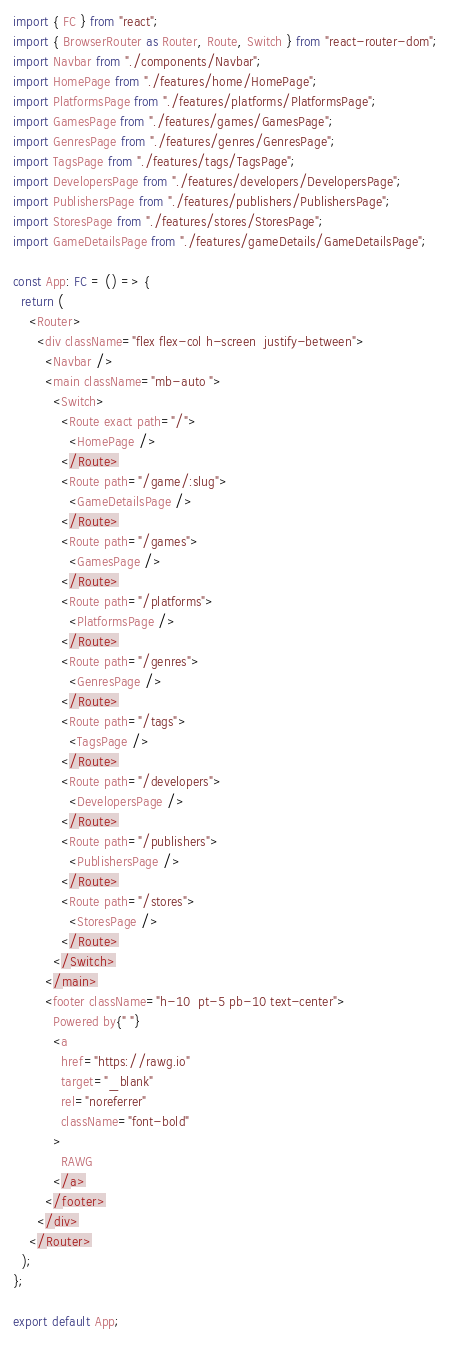<code> <loc_0><loc_0><loc_500><loc_500><_TypeScript_>import { FC } from "react";
import { BrowserRouter as Router, Route, Switch } from "react-router-dom";
import Navbar from "./components/Navbar";
import HomePage from "./features/home/HomePage";
import PlatformsPage from "./features/platforms/PlatformsPage";
import GamesPage from "./features/games/GamesPage";
import GenresPage from "./features/genres/GenresPage";
import TagsPage from "./features/tags/TagsPage";
import DevelopersPage from "./features/developers/DevelopersPage";
import PublishersPage from "./features/publishers/PublishersPage";
import StoresPage from "./features/stores/StoresPage";
import GameDetailsPage from "./features/gameDetails/GameDetailsPage";

const App: FC = () => {
  return (
    <Router>
      <div className="flex flex-col h-screen  justify-between">
        <Navbar />
        <main className="mb-auto ">
          <Switch>
            <Route exact path="/">
              <HomePage />
            </Route>
            <Route path="/game/:slug">
              <GameDetailsPage />
            </Route>
            <Route path="/games">
              <GamesPage />
            </Route>
            <Route path="/platforms">
              <PlatformsPage />
            </Route>
            <Route path="/genres">
              <GenresPage />
            </Route>
            <Route path="/tags">
              <TagsPage />
            </Route>
            <Route path="/developers">
              <DevelopersPage />
            </Route>
            <Route path="/publishers">
              <PublishersPage />
            </Route>
            <Route path="/stores">
              <StoresPage />
            </Route>
          </Switch>
        </main>
        <footer className="h-10  pt-5 pb-10 text-center">
          Powered by{" "}
          <a
            href="https://rawg.io"
            target="_blank"
            rel="noreferrer"
            className="font-bold"
          >
            RAWG
          </a>
        </footer>
      </div>
    </Router>
  );
};

export default App;
</code> 